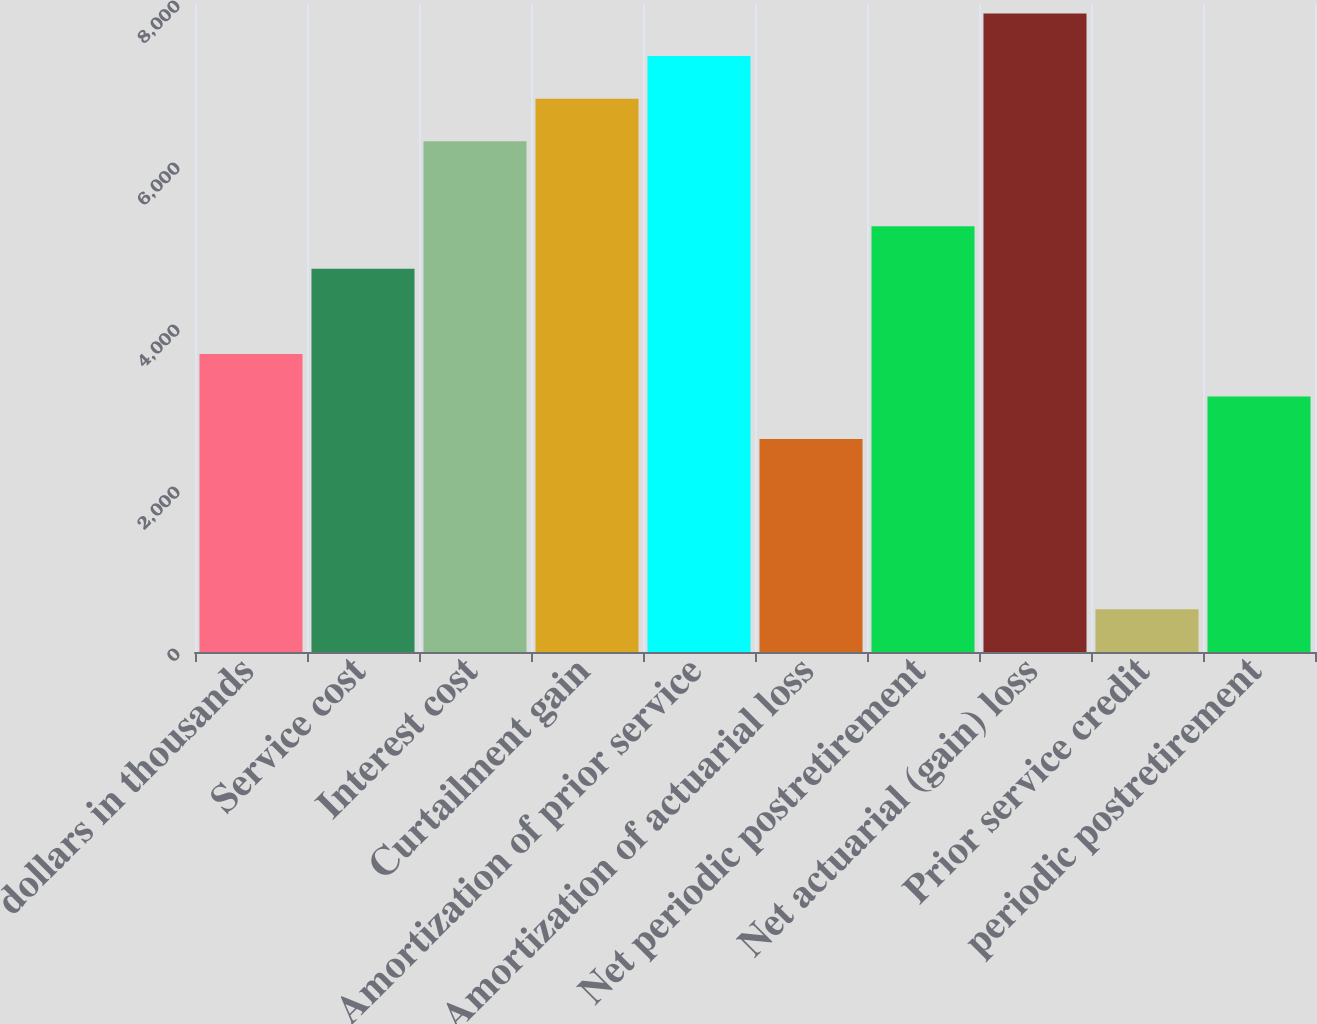<chart> <loc_0><loc_0><loc_500><loc_500><bar_chart><fcel>dollars in thousands<fcel>Service cost<fcel>Interest cost<fcel>Curtailment gain<fcel>Amortization of prior service<fcel>Amortization of actuarial loss<fcel>Net periodic postretirement<fcel>Net actuarial (gain) loss<fcel>Prior service credit<fcel>periodic postretirement<nl><fcel>3680.43<fcel>4730.81<fcel>6306.38<fcel>6831.57<fcel>7356.76<fcel>2630.05<fcel>5256<fcel>7881.95<fcel>529.29<fcel>3155.24<nl></chart> 